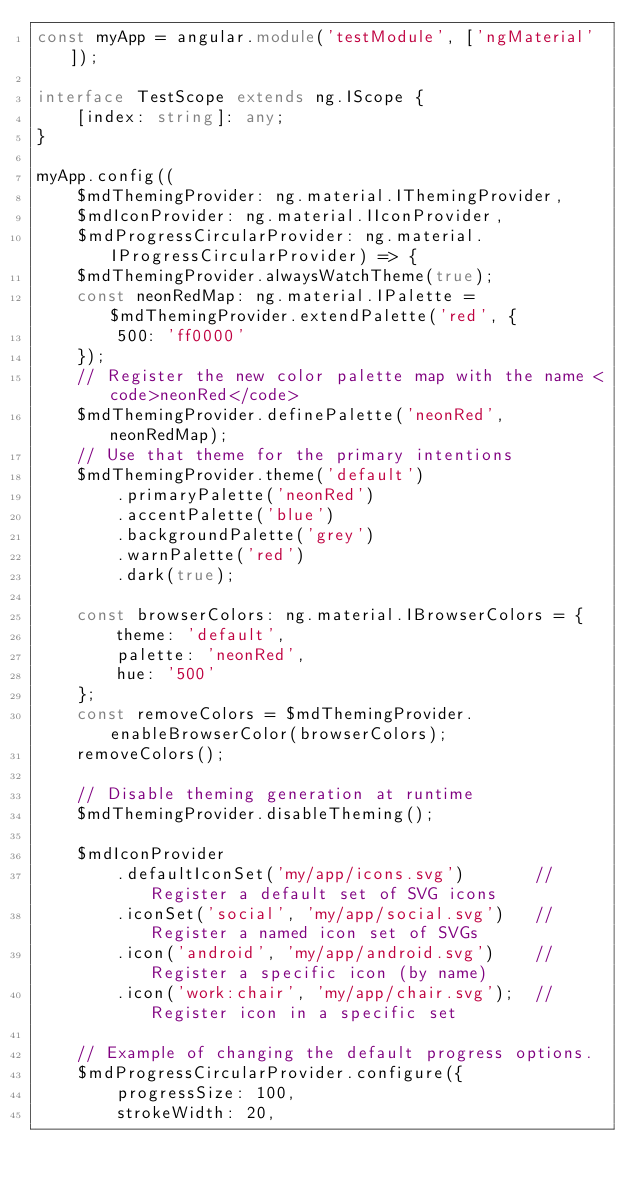Convert code to text. <code><loc_0><loc_0><loc_500><loc_500><_TypeScript_>const myApp = angular.module('testModule', ['ngMaterial']);

interface TestScope extends ng.IScope {
    [index: string]: any;
}

myApp.config((
    $mdThemingProvider: ng.material.IThemingProvider,
    $mdIconProvider: ng.material.IIconProvider,
    $mdProgressCircularProvider: ng.material.IProgressCircularProvider) => {
    $mdThemingProvider.alwaysWatchTheme(true);
    const neonRedMap: ng.material.IPalette = $mdThemingProvider.extendPalette('red', {
        500: 'ff0000'
    });
    // Register the new color palette map with the name <code>neonRed</code>
    $mdThemingProvider.definePalette('neonRed', neonRedMap);
    // Use that theme for the primary intentions
    $mdThemingProvider.theme('default')
        .primaryPalette('neonRed')
        .accentPalette('blue')
        .backgroundPalette('grey')
        .warnPalette('red')
        .dark(true);

    const browserColors: ng.material.IBrowserColors = {
        theme: 'default',
        palette: 'neonRed',
        hue: '500'
    };
    const removeColors = $mdThemingProvider.enableBrowserColor(browserColors);
    removeColors();

    // Disable theming generation at runtime
    $mdThemingProvider.disableTheming();

    $mdIconProvider
        .defaultIconSet('my/app/icons.svg')       // Register a default set of SVG icons
        .iconSet('social', 'my/app/social.svg')   // Register a named icon set of SVGs
        .icon('android', 'my/app/android.svg')    // Register a specific icon (by name)
        .icon('work:chair', 'my/app/chair.svg');  // Register icon in a specific set

    // Example of changing the default progress options.
    $mdProgressCircularProvider.configure({
        progressSize: 100,
        strokeWidth: 20,</code> 